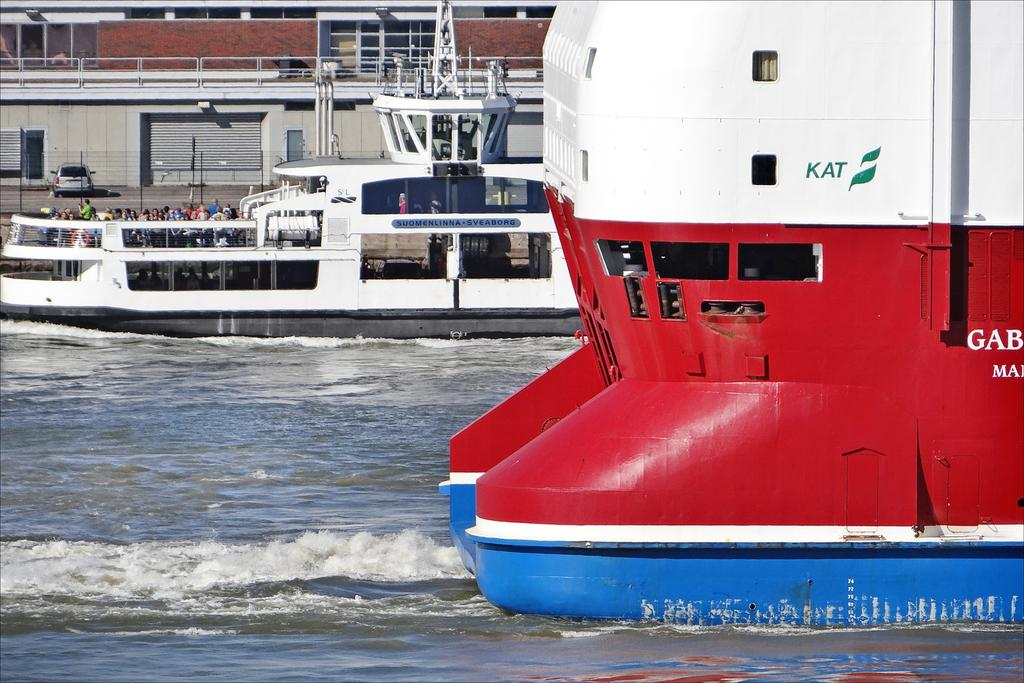<image>
Offer a succinct explanation of the picture presented. A large blue, red and white boat that is passing by has KAT and a green flag on the side of it. 